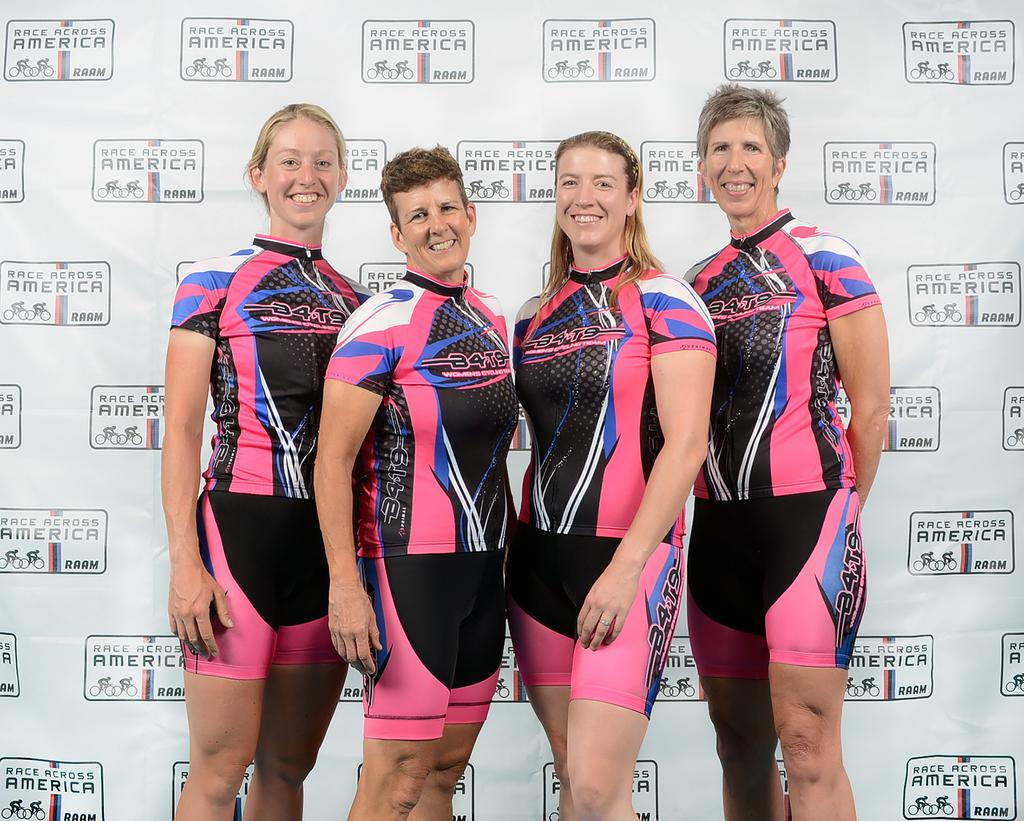Provide a one-sentence caption for the provided image. Four women wearing cycling team uniforms pose in a line. 